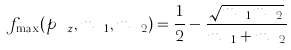Convert formula to latex. <formula><loc_0><loc_0><loc_500><loc_500>f _ { \max } ( p _ { \ z } , m _ { \ 1 } , m _ { \ 2 } ) = \frac { 1 } { 2 } - \frac { \sqrt { m _ { \ 1 } m _ { \ 2 } } } { m _ { \ 1 } + m _ { \ 2 } }</formula> 